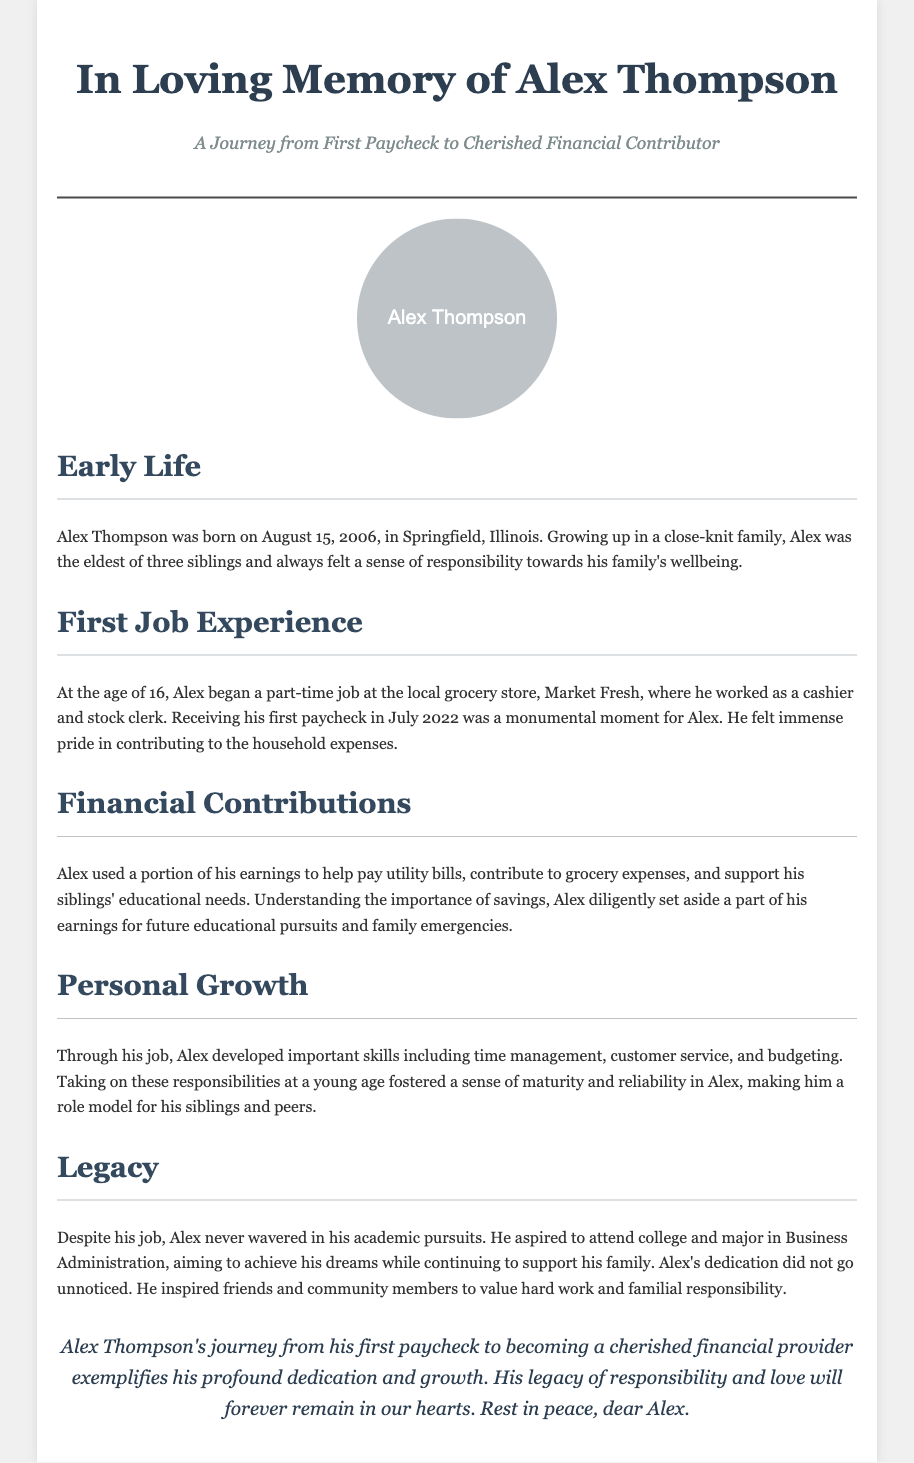What is Alex Thompson's birth date? Alex Thompson was born on August 15, 2006, as stated in the Early Life section.
Answer: August 15, 2006 At what age did Alex begin his first job? Alex began his first job at the age of 16, according to the First Job Experience section.
Answer: 16 What was the name of the grocery store where Alex worked? The document mentions that Alex worked at Market Fresh, his job location in the First Job Experience section.
Answer: Market Fresh What did Alex aspire to major in at college? Alex aspired to major in Business Administration, as noted in the Legacy section.
Answer: Business Administration How did Alex contribute to his family's expenses? The Financial Contributions section states that Alex used his earnings to pay utility bills and support grocery expenses.
Answer: Utility bills and grocery expenses What skills did Alex develop through his job? The Personal Growth section lists important skills such as time management, customer service, and budgeting that Alex developed.
Answer: Time management, customer service, budgeting What was a monumental moment in Alex's job? The document notes that receiving his first paycheck was a monumental moment for Alex in the First Job Experience section.
Answer: First paycheck In what way did Alex's journey impact his community? According to the document, Alex inspired friends and community members to value hard work and familial responsibility.
Answer: Inspired value of hard work and familial responsibility What is the overall theme of the obituary? The document emphasizes Alex's dedication and growth, specifically from his first paycheck to becoming a cherished financial contributor.
Answer: Dedication and growth 